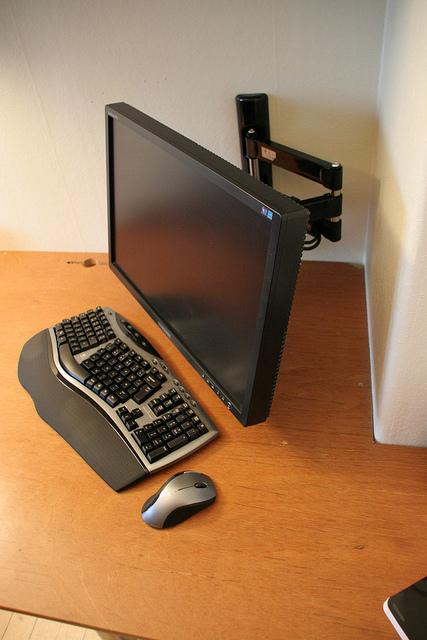What is the mouse next to?

Choices:
A) cat
B) goat
C) keyboard
D) cherry keyboard 